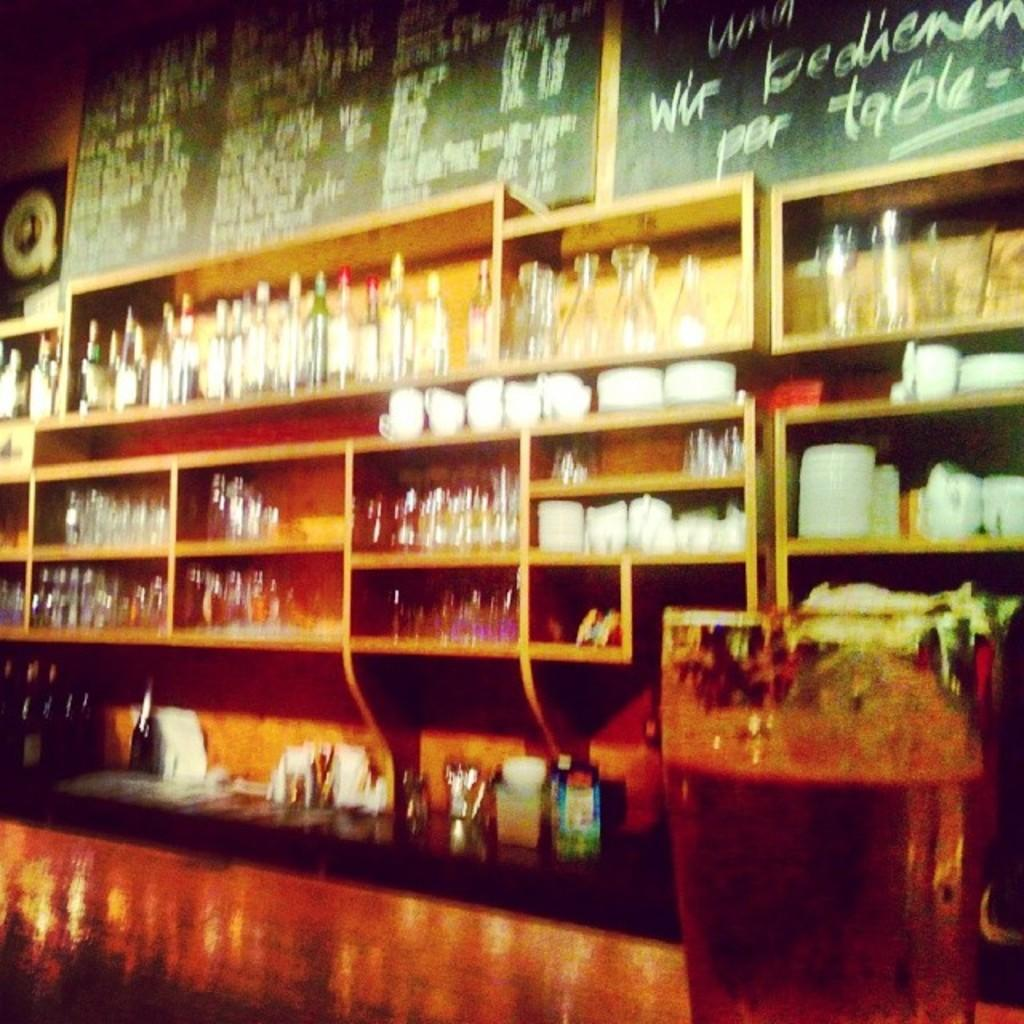Provide a one-sentence caption for the provided image. A bar with lots of bottles on shelves with a chalkboard that says por table. 